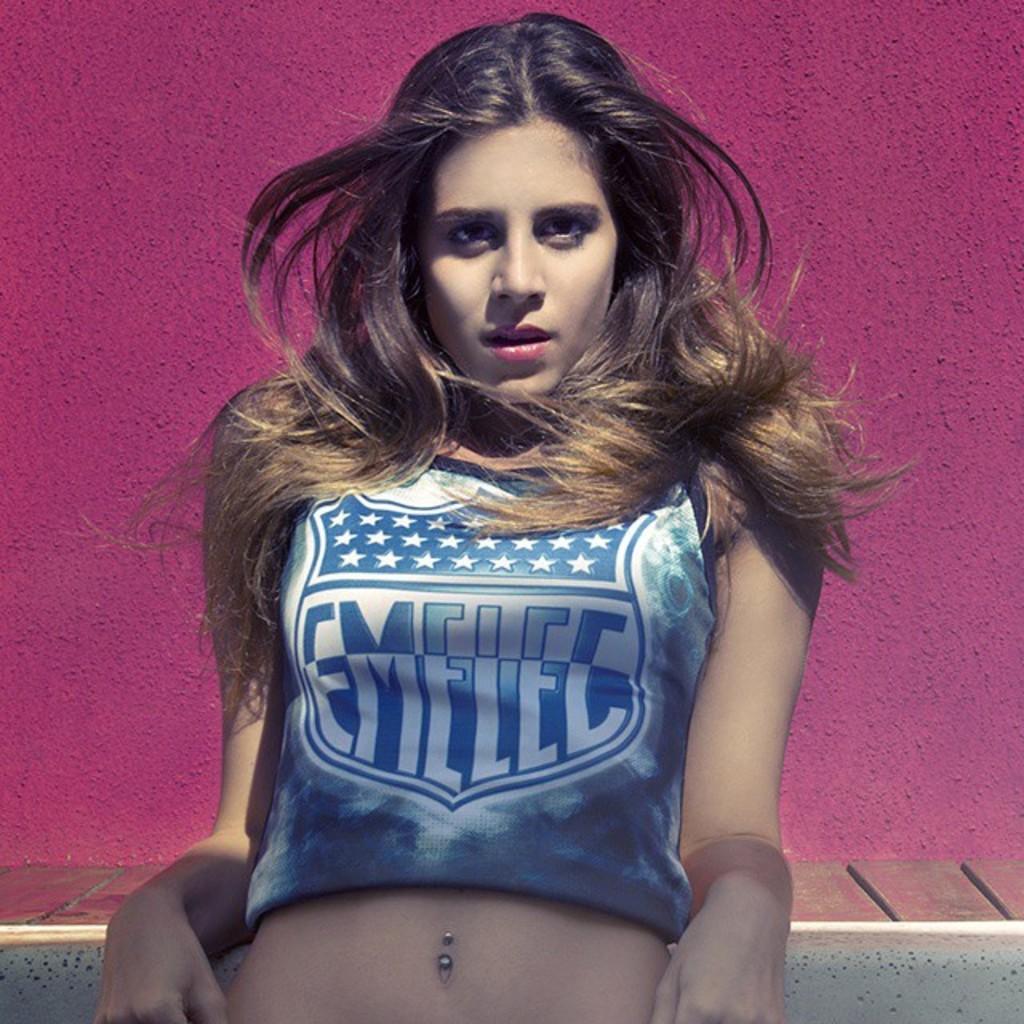What soccer team does she support?
Your response must be concise. Emelec. The soccer team does support the emelec?
Offer a terse response. Yes. 